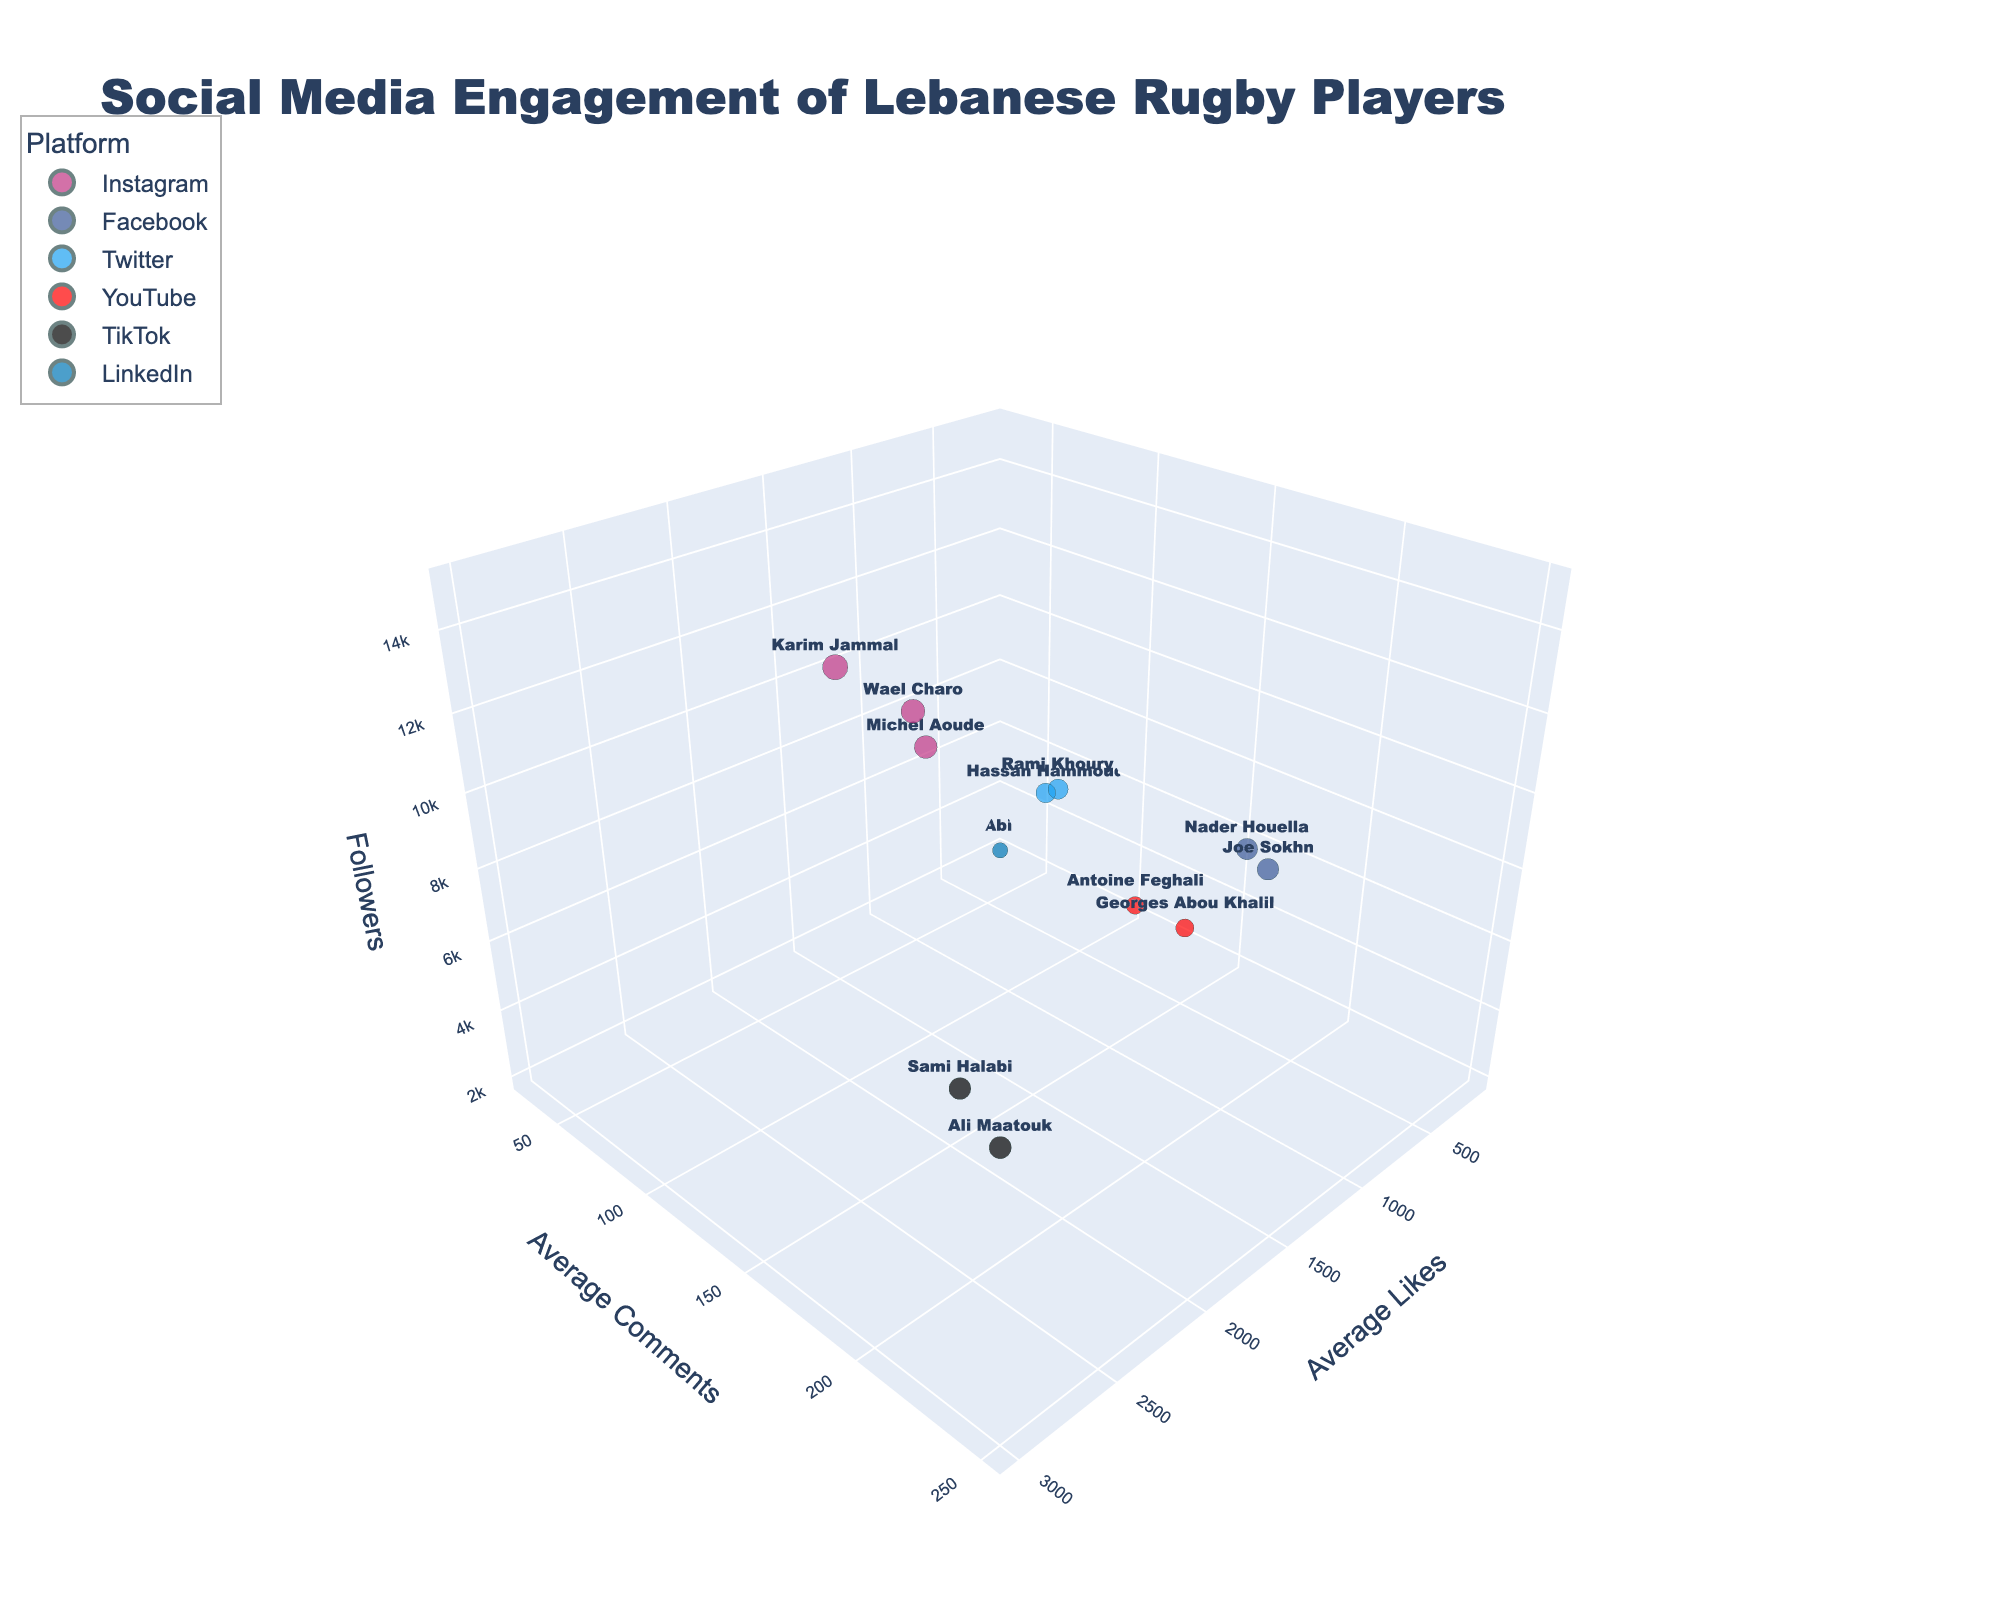What is the axis title for the x-axis? The x-axis title is displayed in the figure, denoting the variable it represents. By visually checking the figure, we find that the title is 'Average Likes'.
Answer: Average Likes Which player has the highest average likes on Instagram? To find this, look at the bubbles corresponding to Instagram (color-coded) and check for the highest 'Avg Likes'. Karim Jammal has the highest average likes.
Answer: Karim Jammal How many platforms are represented in the chart and what are they? By examining the color legend in the chart, we see different colors representing different platforms. Counting these colors, we get six platforms: Instagram, Facebook, Twitter, YouTube, TikTok, LinkedIn.
Answer: Six platforms: Instagram, Facebook, Twitter, YouTube, TikTok, LinkedIn Who has more followers: Michel Aoude or Wael Charo? Locate the bubbles for Michel Aoude and Wael Charo and check their 'Followers' values along the z-axis. Michel Aoude has 10,000 followers, and Wael Charo has 12,000 followers. Wael Charo has more followers.
Answer: Wael Charo What is the average number of comments for players on TikTok? Locate the bubbles for TikTok (black color) then find 'Avg Comments' for Ali Maatouk (250) and Sami Halabi (220). Calculate the average: (250 + 220) / 2 = 235.
Answer: 235 Which player on YouTube has more average likes: Georges Abou Khalil or Antoine Feghali? Look for the YouTube bubbles and compare 'Avg Likes' values. Georges Abou Khalil has 500 and Antoine Feghali has 400. Georges Abou Khalil has more average likes.
Answer: Georges Abou Khalil Among all the social media platforms, which player's content generates the most average comments? Look across all platforms and check the height (y-axis) for 'Avg Comments'. Ali Maatouk on TikTok has the highest with 250 comments.
Answer: Ali Maatouk Which two players have the closest average number of likes? Visually scan through the x-axis values (average likes) and compare values that are near each other. Wael Charo (1800) and Michel Aoude (1500) on Instagram have very close values.
Answer: Wael Charo and Michel Aoude What's the combined number of followers for all players on Facebook? Identify Facebook players (Joe Sokhn and Nader Houella), then sum their followers: 8,000 + 7,500 = 15,500.
Answer: 15,500 